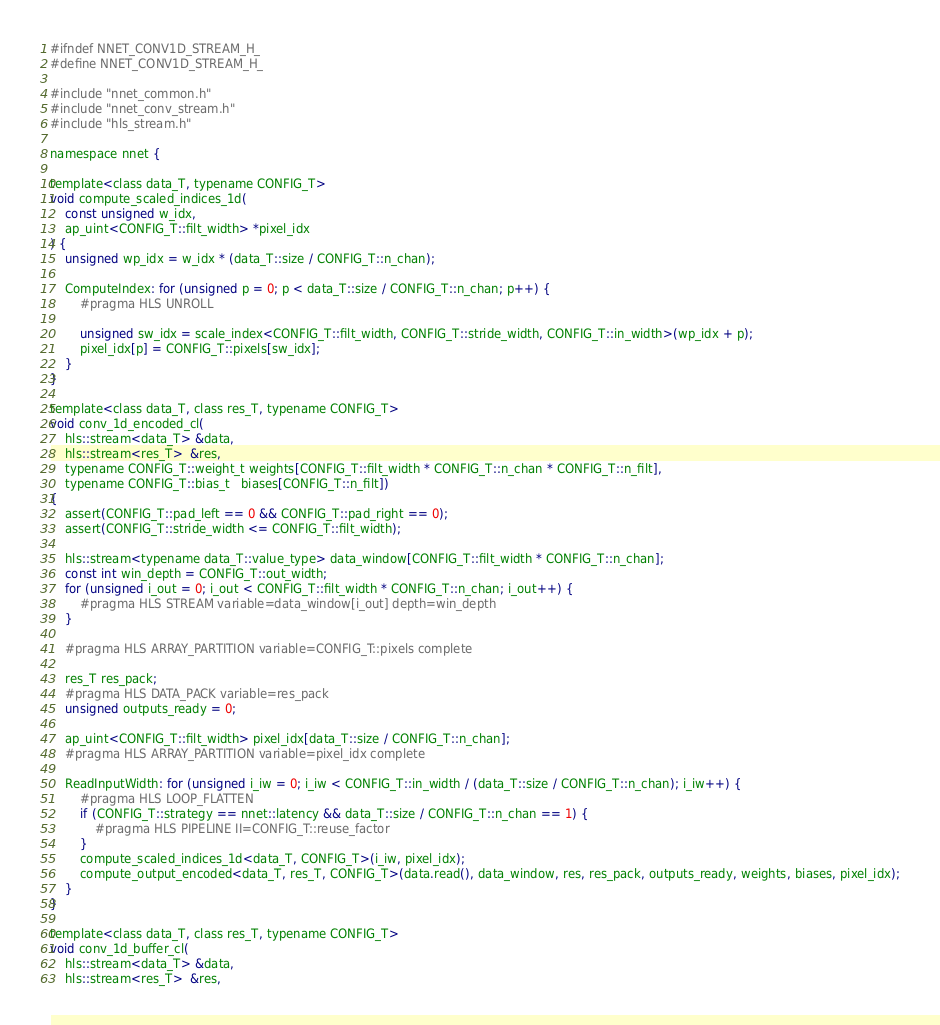<code> <loc_0><loc_0><loc_500><loc_500><_C_>#ifndef NNET_CONV1D_STREAM_H_
#define NNET_CONV1D_STREAM_H_

#include "nnet_common.h"
#include "nnet_conv_stream.h"
#include "hls_stream.h"

namespace nnet {

template<class data_T, typename CONFIG_T>
void compute_scaled_indices_1d(
    const unsigned w_idx,
    ap_uint<CONFIG_T::filt_width> *pixel_idx
) {
    unsigned wp_idx = w_idx * (data_T::size / CONFIG_T::n_chan);

    ComputeIndex: for (unsigned p = 0; p < data_T::size / CONFIG_T::n_chan; p++) {
        #pragma HLS UNROLL

        unsigned sw_idx = scale_index<CONFIG_T::filt_width, CONFIG_T::stride_width, CONFIG_T::in_width>(wp_idx + p);
        pixel_idx[p] = CONFIG_T::pixels[sw_idx];
    }
}

template<class data_T, class res_T, typename CONFIG_T>
void conv_1d_encoded_cl(
    hls::stream<data_T> &data,
    hls::stream<res_T>  &res,
    typename CONFIG_T::weight_t weights[CONFIG_T::filt_width * CONFIG_T::n_chan * CONFIG_T::n_filt],
    typename CONFIG_T::bias_t   biases[CONFIG_T::n_filt])
{
    assert(CONFIG_T::pad_left == 0 && CONFIG_T::pad_right == 0);
    assert(CONFIG_T::stride_width <= CONFIG_T::filt_width);

    hls::stream<typename data_T::value_type> data_window[CONFIG_T::filt_width * CONFIG_T::n_chan];
    const int win_depth = CONFIG_T::out_width;
    for (unsigned i_out = 0; i_out < CONFIG_T::filt_width * CONFIG_T::n_chan; i_out++) {
        #pragma HLS STREAM variable=data_window[i_out] depth=win_depth
    }

    #pragma HLS ARRAY_PARTITION variable=CONFIG_T::pixels complete

    res_T res_pack;
    #pragma HLS DATA_PACK variable=res_pack
    unsigned outputs_ready = 0;

    ap_uint<CONFIG_T::filt_width> pixel_idx[data_T::size / CONFIG_T::n_chan];
    #pragma HLS ARRAY_PARTITION variable=pixel_idx complete

    ReadInputWidth: for (unsigned i_iw = 0; i_iw < CONFIG_T::in_width / (data_T::size / CONFIG_T::n_chan); i_iw++) {
        #pragma HLS LOOP_FLATTEN
        if (CONFIG_T::strategy == nnet::latency && data_T::size / CONFIG_T::n_chan == 1) {
            #pragma HLS PIPELINE II=CONFIG_T::reuse_factor
        }
        compute_scaled_indices_1d<data_T, CONFIG_T>(i_iw, pixel_idx);
        compute_output_encoded<data_T, res_T, CONFIG_T>(data.read(), data_window, res, res_pack, outputs_ready, weights, biases, pixel_idx);
    }
}

template<class data_T, class res_T, typename CONFIG_T>
void conv_1d_buffer_cl(
    hls::stream<data_T> &data,
    hls::stream<res_T>  &res,</code> 